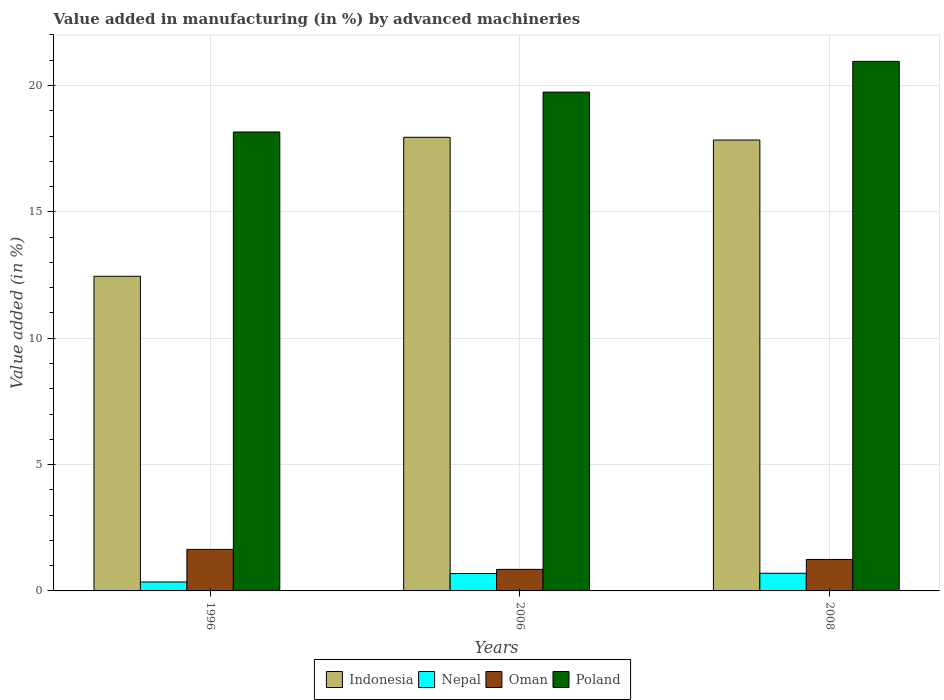How many groups of bars are there?
Offer a very short reply. 3. Are the number of bars per tick equal to the number of legend labels?
Your answer should be compact. Yes. What is the percentage of value added in manufacturing by advanced machineries in Oman in 2008?
Your answer should be compact. 1.25. Across all years, what is the maximum percentage of value added in manufacturing by advanced machineries in Nepal?
Provide a short and direct response. 0.7. Across all years, what is the minimum percentage of value added in manufacturing by advanced machineries in Nepal?
Give a very brief answer. 0.35. In which year was the percentage of value added in manufacturing by advanced machineries in Nepal maximum?
Ensure brevity in your answer.  2008. In which year was the percentage of value added in manufacturing by advanced machineries in Indonesia minimum?
Offer a very short reply. 1996. What is the total percentage of value added in manufacturing by advanced machineries in Oman in the graph?
Provide a succinct answer. 3.74. What is the difference between the percentage of value added in manufacturing by advanced machineries in Oman in 2006 and that in 2008?
Provide a short and direct response. -0.39. What is the difference between the percentage of value added in manufacturing by advanced machineries in Poland in 2006 and the percentage of value added in manufacturing by advanced machineries in Oman in 1996?
Your answer should be very brief. 18.1. What is the average percentage of value added in manufacturing by advanced machineries in Indonesia per year?
Provide a succinct answer. 16.08. In the year 2006, what is the difference between the percentage of value added in manufacturing by advanced machineries in Oman and percentage of value added in manufacturing by advanced machineries in Poland?
Your answer should be very brief. -18.89. In how many years, is the percentage of value added in manufacturing by advanced machineries in Nepal greater than 7 %?
Keep it short and to the point. 0. What is the ratio of the percentage of value added in manufacturing by advanced machineries in Nepal in 1996 to that in 2008?
Your answer should be compact. 0.51. Is the difference between the percentage of value added in manufacturing by advanced machineries in Oman in 1996 and 2008 greater than the difference between the percentage of value added in manufacturing by advanced machineries in Poland in 1996 and 2008?
Keep it short and to the point. Yes. What is the difference between the highest and the second highest percentage of value added in manufacturing by advanced machineries in Nepal?
Keep it short and to the point. 0.01. What is the difference between the highest and the lowest percentage of value added in manufacturing by advanced machineries in Oman?
Your answer should be compact. 0.79. In how many years, is the percentage of value added in manufacturing by advanced machineries in Indonesia greater than the average percentage of value added in manufacturing by advanced machineries in Indonesia taken over all years?
Ensure brevity in your answer.  2. Is the sum of the percentage of value added in manufacturing by advanced machineries in Nepal in 1996 and 2006 greater than the maximum percentage of value added in manufacturing by advanced machineries in Poland across all years?
Your response must be concise. No. What does the 4th bar from the left in 1996 represents?
Your response must be concise. Poland. What does the 3rd bar from the right in 2008 represents?
Ensure brevity in your answer.  Nepal. How many bars are there?
Your response must be concise. 12. Are all the bars in the graph horizontal?
Give a very brief answer. No. What is the difference between two consecutive major ticks on the Y-axis?
Offer a very short reply. 5. Are the values on the major ticks of Y-axis written in scientific E-notation?
Provide a succinct answer. No. Does the graph contain grids?
Offer a terse response. Yes. Where does the legend appear in the graph?
Your response must be concise. Bottom center. How are the legend labels stacked?
Make the answer very short. Horizontal. What is the title of the graph?
Your response must be concise. Value added in manufacturing (in %) by advanced machineries. Does "Sierra Leone" appear as one of the legend labels in the graph?
Provide a succinct answer. No. What is the label or title of the Y-axis?
Make the answer very short. Value added (in %). What is the Value added (in %) in Indonesia in 1996?
Offer a very short reply. 12.45. What is the Value added (in %) of Nepal in 1996?
Your answer should be very brief. 0.35. What is the Value added (in %) in Oman in 1996?
Ensure brevity in your answer.  1.64. What is the Value added (in %) in Poland in 1996?
Give a very brief answer. 18.16. What is the Value added (in %) of Indonesia in 2006?
Provide a short and direct response. 17.95. What is the Value added (in %) of Nepal in 2006?
Offer a terse response. 0.69. What is the Value added (in %) in Oman in 2006?
Your answer should be compact. 0.85. What is the Value added (in %) of Poland in 2006?
Keep it short and to the point. 19.74. What is the Value added (in %) in Indonesia in 2008?
Offer a terse response. 17.84. What is the Value added (in %) in Nepal in 2008?
Offer a terse response. 0.7. What is the Value added (in %) of Oman in 2008?
Offer a terse response. 1.25. What is the Value added (in %) of Poland in 2008?
Provide a succinct answer. 20.95. Across all years, what is the maximum Value added (in %) of Indonesia?
Your response must be concise. 17.95. Across all years, what is the maximum Value added (in %) in Nepal?
Keep it short and to the point. 0.7. Across all years, what is the maximum Value added (in %) in Oman?
Your answer should be very brief. 1.64. Across all years, what is the maximum Value added (in %) of Poland?
Ensure brevity in your answer.  20.95. Across all years, what is the minimum Value added (in %) of Indonesia?
Offer a very short reply. 12.45. Across all years, what is the minimum Value added (in %) in Nepal?
Make the answer very short. 0.35. Across all years, what is the minimum Value added (in %) in Oman?
Ensure brevity in your answer.  0.85. Across all years, what is the minimum Value added (in %) of Poland?
Provide a succinct answer. 18.16. What is the total Value added (in %) in Indonesia in the graph?
Give a very brief answer. 48.24. What is the total Value added (in %) of Nepal in the graph?
Keep it short and to the point. 1.74. What is the total Value added (in %) in Oman in the graph?
Your answer should be very brief. 3.74. What is the total Value added (in %) in Poland in the graph?
Provide a short and direct response. 58.85. What is the difference between the Value added (in %) of Indonesia in 1996 and that in 2006?
Give a very brief answer. -5.5. What is the difference between the Value added (in %) in Nepal in 1996 and that in 2006?
Offer a very short reply. -0.33. What is the difference between the Value added (in %) of Oman in 1996 and that in 2006?
Make the answer very short. 0.79. What is the difference between the Value added (in %) of Poland in 1996 and that in 2006?
Your answer should be very brief. -1.58. What is the difference between the Value added (in %) of Indonesia in 1996 and that in 2008?
Provide a succinct answer. -5.39. What is the difference between the Value added (in %) in Nepal in 1996 and that in 2008?
Ensure brevity in your answer.  -0.34. What is the difference between the Value added (in %) of Oman in 1996 and that in 2008?
Offer a very short reply. 0.4. What is the difference between the Value added (in %) of Poland in 1996 and that in 2008?
Your response must be concise. -2.79. What is the difference between the Value added (in %) of Indonesia in 2006 and that in 2008?
Make the answer very short. 0.11. What is the difference between the Value added (in %) of Nepal in 2006 and that in 2008?
Provide a short and direct response. -0.01. What is the difference between the Value added (in %) in Oman in 2006 and that in 2008?
Give a very brief answer. -0.39. What is the difference between the Value added (in %) in Poland in 2006 and that in 2008?
Your answer should be compact. -1.22. What is the difference between the Value added (in %) in Indonesia in 1996 and the Value added (in %) in Nepal in 2006?
Provide a succinct answer. 11.76. What is the difference between the Value added (in %) of Indonesia in 1996 and the Value added (in %) of Oman in 2006?
Ensure brevity in your answer.  11.6. What is the difference between the Value added (in %) of Indonesia in 1996 and the Value added (in %) of Poland in 2006?
Make the answer very short. -7.29. What is the difference between the Value added (in %) in Nepal in 1996 and the Value added (in %) in Oman in 2006?
Provide a succinct answer. -0.5. What is the difference between the Value added (in %) of Nepal in 1996 and the Value added (in %) of Poland in 2006?
Keep it short and to the point. -19.38. What is the difference between the Value added (in %) of Oman in 1996 and the Value added (in %) of Poland in 2006?
Your answer should be compact. -18.1. What is the difference between the Value added (in %) of Indonesia in 1996 and the Value added (in %) of Nepal in 2008?
Provide a succinct answer. 11.75. What is the difference between the Value added (in %) of Indonesia in 1996 and the Value added (in %) of Oman in 2008?
Provide a short and direct response. 11.21. What is the difference between the Value added (in %) of Indonesia in 1996 and the Value added (in %) of Poland in 2008?
Offer a very short reply. -8.5. What is the difference between the Value added (in %) of Nepal in 1996 and the Value added (in %) of Oman in 2008?
Keep it short and to the point. -0.89. What is the difference between the Value added (in %) in Nepal in 1996 and the Value added (in %) in Poland in 2008?
Provide a short and direct response. -20.6. What is the difference between the Value added (in %) in Oman in 1996 and the Value added (in %) in Poland in 2008?
Offer a very short reply. -19.31. What is the difference between the Value added (in %) of Indonesia in 2006 and the Value added (in %) of Nepal in 2008?
Keep it short and to the point. 17.25. What is the difference between the Value added (in %) of Indonesia in 2006 and the Value added (in %) of Oman in 2008?
Offer a terse response. 16.7. What is the difference between the Value added (in %) in Indonesia in 2006 and the Value added (in %) in Poland in 2008?
Give a very brief answer. -3.01. What is the difference between the Value added (in %) in Nepal in 2006 and the Value added (in %) in Oman in 2008?
Make the answer very short. -0.56. What is the difference between the Value added (in %) of Nepal in 2006 and the Value added (in %) of Poland in 2008?
Your response must be concise. -20.27. What is the difference between the Value added (in %) of Oman in 2006 and the Value added (in %) of Poland in 2008?
Your answer should be compact. -20.1. What is the average Value added (in %) in Indonesia per year?
Your answer should be very brief. 16.08. What is the average Value added (in %) of Nepal per year?
Your response must be concise. 0.58. What is the average Value added (in %) of Oman per year?
Provide a succinct answer. 1.25. What is the average Value added (in %) of Poland per year?
Your answer should be compact. 19.62. In the year 1996, what is the difference between the Value added (in %) of Indonesia and Value added (in %) of Nepal?
Provide a succinct answer. 12.1. In the year 1996, what is the difference between the Value added (in %) in Indonesia and Value added (in %) in Oman?
Keep it short and to the point. 10.81. In the year 1996, what is the difference between the Value added (in %) in Indonesia and Value added (in %) in Poland?
Offer a very short reply. -5.71. In the year 1996, what is the difference between the Value added (in %) of Nepal and Value added (in %) of Oman?
Keep it short and to the point. -1.29. In the year 1996, what is the difference between the Value added (in %) in Nepal and Value added (in %) in Poland?
Provide a succinct answer. -17.81. In the year 1996, what is the difference between the Value added (in %) in Oman and Value added (in %) in Poland?
Your response must be concise. -16.52. In the year 2006, what is the difference between the Value added (in %) of Indonesia and Value added (in %) of Nepal?
Keep it short and to the point. 17.26. In the year 2006, what is the difference between the Value added (in %) of Indonesia and Value added (in %) of Oman?
Offer a very short reply. 17.1. In the year 2006, what is the difference between the Value added (in %) of Indonesia and Value added (in %) of Poland?
Ensure brevity in your answer.  -1.79. In the year 2006, what is the difference between the Value added (in %) of Nepal and Value added (in %) of Oman?
Your response must be concise. -0.17. In the year 2006, what is the difference between the Value added (in %) of Nepal and Value added (in %) of Poland?
Make the answer very short. -19.05. In the year 2006, what is the difference between the Value added (in %) in Oman and Value added (in %) in Poland?
Offer a terse response. -18.89. In the year 2008, what is the difference between the Value added (in %) of Indonesia and Value added (in %) of Nepal?
Your answer should be very brief. 17.14. In the year 2008, what is the difference between the Value added (in %) of Indonesia and Value added (in %) of Oman?
Make the answer very short. 16.6. In the year 2008, what is the difference between the Value added (in %) of Indonesia and Value added (in %) of Poland?
Your answer should be compact. -3.11. In the year 2008, what is the difference between the Value added (in %) of Nepal and Value added (in %) of Oman?
Provide a succinct answer. -0.55. In the year 2008, what is the difference between the Value added (in %) of Nepal and Value added (in %) of Poland?
Provide a succinct answer. -20.26. In the year 2008, what is the difference between the Value added (in %) in Oman and Value added (in %) in Poland?
Give a very brief answer. -19.71. What is the ratio of the Value added (in %) of Indonesia in 1996 to that in 2006?
Provide a succinct answer. 0.69. What is the ratio of the Value added (in %) of Nepal in 1996 to that in 2006?
Keep it short and to the point. 0.51. What is the ratio of the Value added (in %) of Oman in 1996 to that in 2006?
Make the answer very short. 1.93. What is the ratio of the Value added (in %) in Indonesia in 1996 to that in 2008?
Your answer should be very brief. 0.7. What is the ratio of the Value added (in %) of Nepal in 1996 to that in 2008?
Give a very brief answer. 0.51. What is the ratio of the Value added (in %) in Oman in 1996 to that in 2008?
Your answer should be compact. 1.32. What is the ratio of the Value added (in %) of Poland in 1996 to that in 2008?
Keep it short and to the point. 0.87. What is the ratio of the Value added (in %) of Indonesia in 2006 to that in 2008?
Your answer should be very brief. 1.01. What is the ratio of the Value added (in %) in Nepal in 2006 to that in 2008?
Provide a succinct answer. 0.98. What is the ratio of the Value added (in %) in Oman in 2006 to that in 2008?
Offer a terse response. 0.68. What is the ratio of the Value added (in %) of Poland in 2006 to that in 2008?
Provide a succinct answer. 0.94. What is the difference between the highest and the second highest Value added (in %) in Indonesia?
Provide a succinct answer. 0.11. What is the difference between the highest and the second highest Value added (in %) in Nepal?
Make the answer very short. 0.01. What is the difference between the highest and the second highest Value added (in %) of Oman?
Make the answer very short. 0.4. What is the difference between the highest and the second highest Value added (in %) of Poland?
Give a very brief answer. 1.22. What is the difference between the highest and the lowest Value added (in %) in Indonesia?
Keep it short and to the point. 5.5. What is the difference between the highest and the lowest Value added (in %) in Nepal?
Provide a succinct answer. 0.34. What is the difference between the highest and the lowest Value added (in %) of Oman?
Provide a succinct answer. 0.79. What is the difference between the highest and the lowest Value added (in %) of Poland?
Offer a terse response. 2.79. 